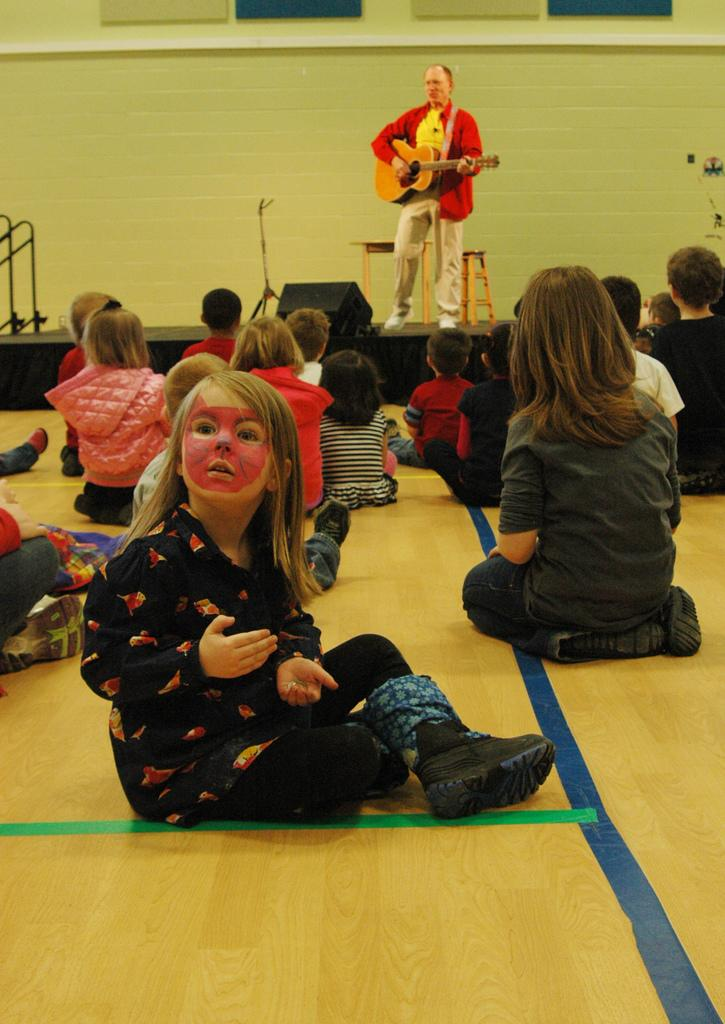What are the kids in the image doing? The kids in the image are sitting on the floor. Where is the person playing a guitar located in the image? The person playing a guitar is on a stage. What color is the patch on the guitar in the image? There is no patch mentioned or visible on the guitar in the image. 